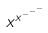Convert formula to latex. <formula><loc_0><loc_0><loc_500><loc_500>x ^ { x ^ { - ^ { - ^ { - } } } }</formula> 